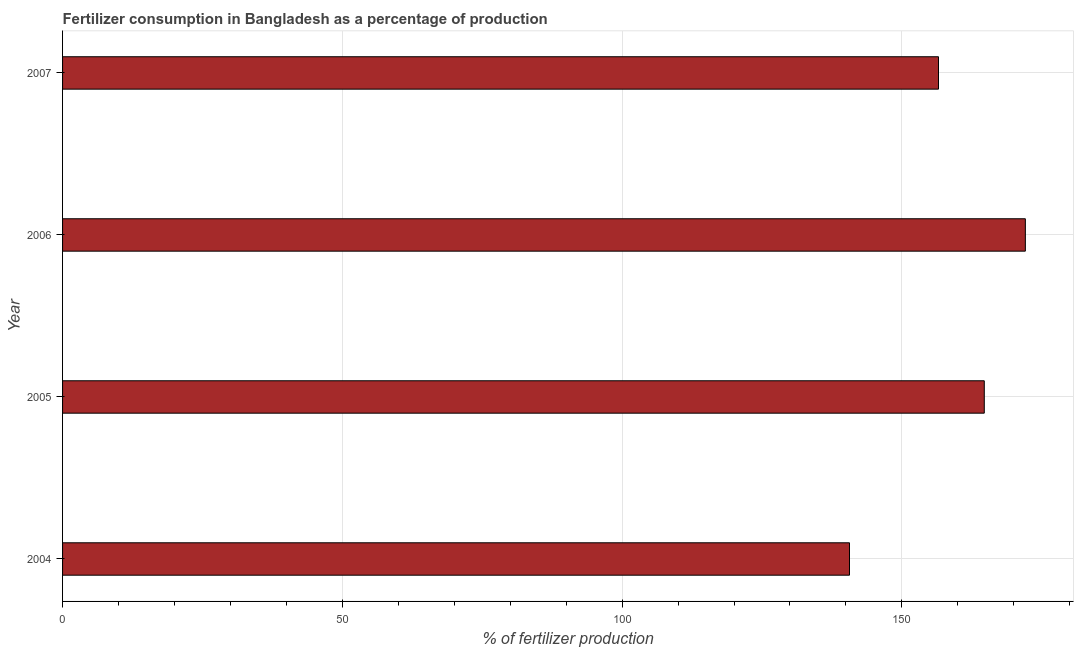Does the graph contain grids?
Your answer should be compact. Yes. What is the title of the graph?
Offer a terse response. Fertilizer consumption in Bangladesh as a percentage of production. What is the label or title of the X-axis?
Give a very brief answer. % of fertilizer production. What is the amount of fertilizer consumption in 2007?
Offer a terse response. 156.55. Across all years, what is the maximum amount of fertilizer consumption?
Your answer should be compact. 172.07. Across all years, what is the minimum amount of fertilizer consumption?
Your response must be concise. 140.64. In which year was the amount of fertilizer consumption maximum?
Offer a terse response. 2006. What is the sum of the amount of fertilizer consumption?
Ensure brevity in your answer.  633.99. What is the difference between the amount of fertilizer consumption in 2004 and 2006?
Keep it short and to the point. -31.43. What is the average amount of fertilizer consumption per year?
Provide a succinct answer. 158.5. What is the median amount of fertilizer consumption?
Give a very brief answer. 160.64. Do a majority of the years between 2007 and 2005 (inclusive) have amount of fertilizer consumption greater than 20 %?
Provide a succinct answer. Yes. What is the ratio of the amount of fertilizer consumption in 2005 to that in 2007?
Offer a very short reply. 1.05. Is the amount of fertilizer consumption in 2004 less than that in 2005?
Provide a succinct answer. Yes. Is the difference between the amount of fertilizer consumption in 2004 and 2005 greater than the difference between any two years?
Give a very brief answer. No. What is the difference between the highest and the second highest amount of fertilizer consumption?
Provide a succinct answer. 7.34. Is the sum of the amount of fertilizer consumption in 2004 and 2005 greater than the maximum amount of fertilizer consumption across all years?
Offer a very short reply. Yes. What is the difference between the highest and the lowest amount of fertilizer consumption?
Keep it short and to the point. 31.43. How many years are there in the graph?
Give a very brief answer. 4. Are the values on the major ticks of X-axis written in scientific E-notation?
Your response must be concise. No. What is the % of fertilizer production in 2004?
Give a very brief answer. 140.64. What is the % of fertilizer production of 2005?
Make the answer very short. 164.73. What is the % of fertilizer production in 2006?
Make the answer very short. 172.07. What is the % of fertilizer production of 2007?
Provide a succinct answer. 156.55. What is the difference between the % of fertilizer production in 2004 and 2005?
Ensure brevity in your answer.  -24.09. What is the difference between the % of fertilizer production in 2004 and 2006?
Give a very brief answer. -31.43. What is the difference between the % of fertilizer production in 2004 and 2007?
Provide a short and direct response. -15.91. What is the difference between the % of fertilizer production in 2005 and 2006?
Your answer should be very brief. -7.34. What is the difference between the % of fertilizer production in 2005 and 2007?
Your response must be concise. 8.18. What is the difference between the % of fertilizer production in 2006 and 2007?
Offer a very short reply. 15.52. What is the ratio of the % of fertilizer production in 2004 to that in 2005?
Offer a very short reply. 0.85. What is the ratio of the % of fertilizer production in 2004 to that in 2006?
Ensure brevity in your answer.  0.82. What is the ratio of the % of fertilizer production in 2004 to that in 2007?
Ensure brevity in your answer.  0.9. What is the ratio of the % of fertilizer production in 2005 to that in 2006?
Give a very brief answer. 0.96. What is the ratio of the % of fertilizer production in 2005 to that in 2007?
Give a very brief answer. 1.05. What is the ratio of the % of fertilizer production in 2006 to that in 2007?
Offer a very short reply. 1.1. 